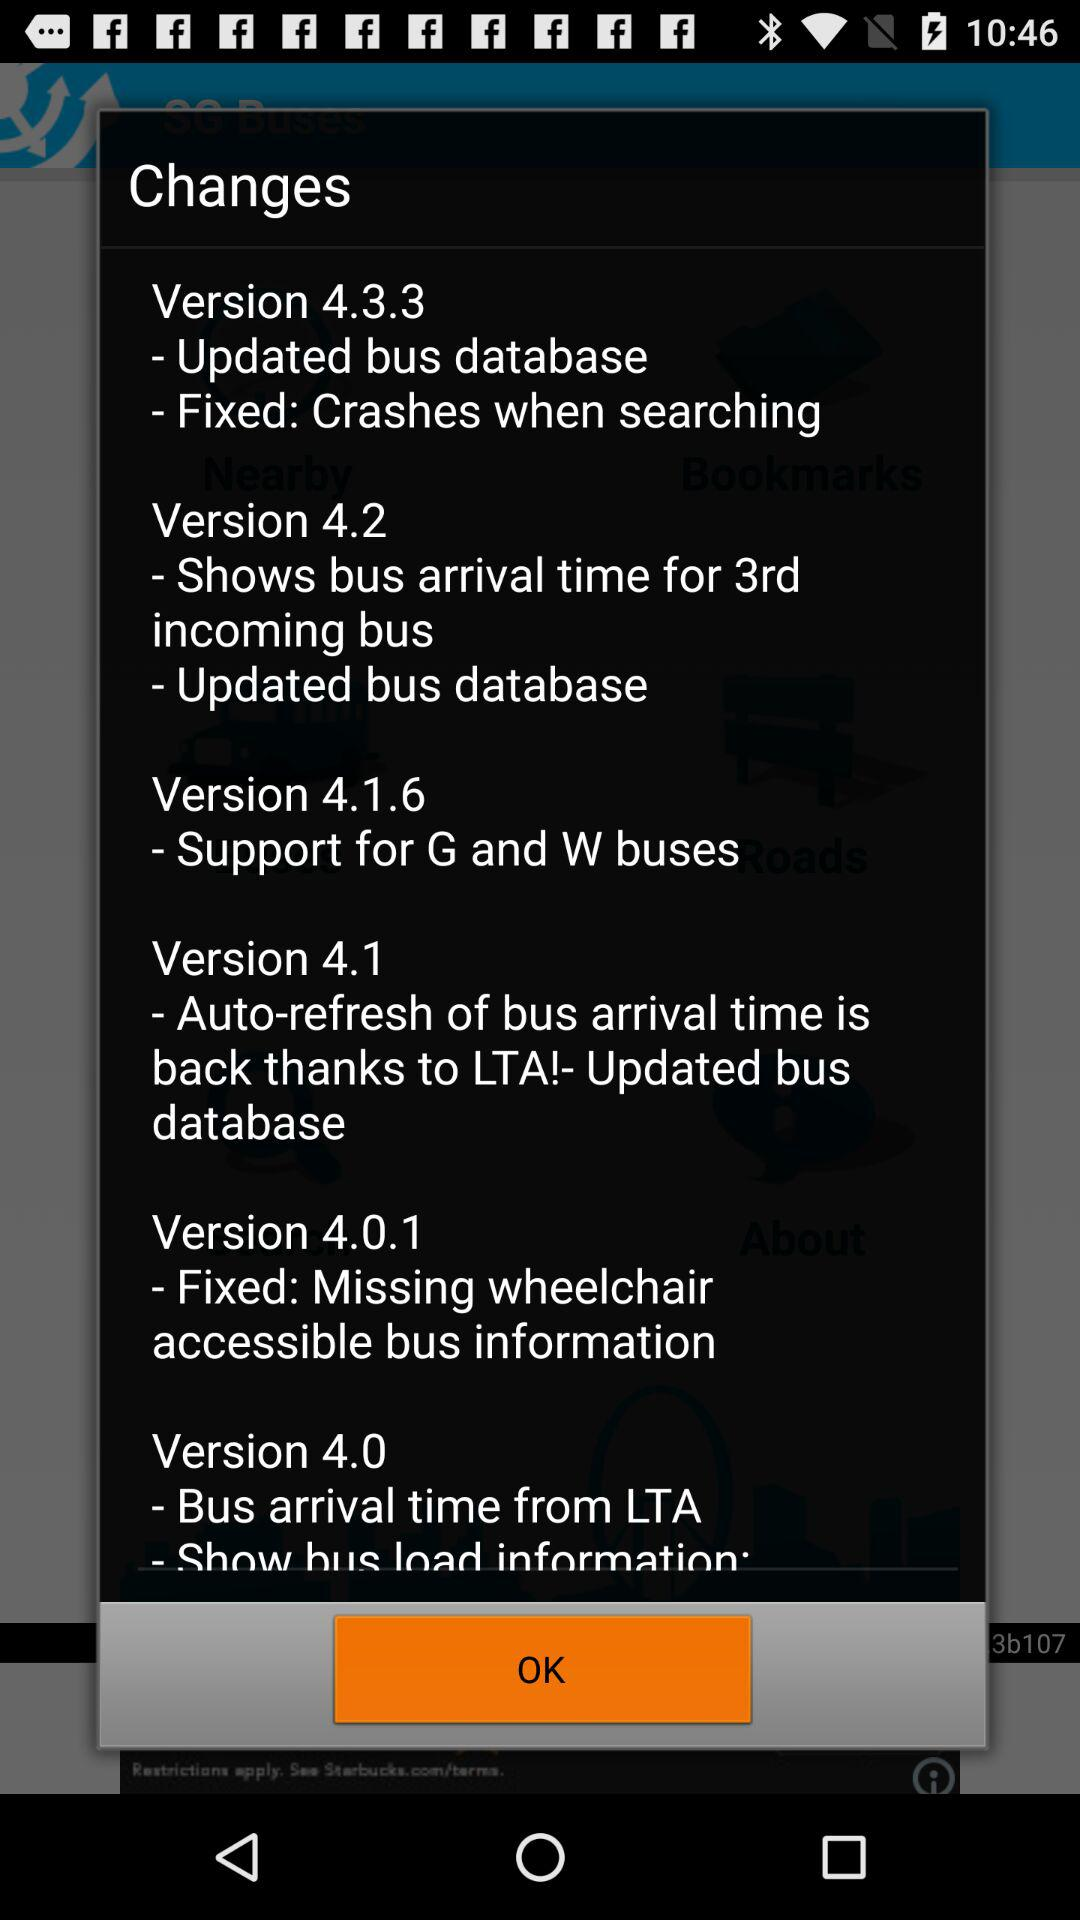What are the updates to version 4.0.1? The update is "Fixed: Missing wheelchair accessible bus information". 